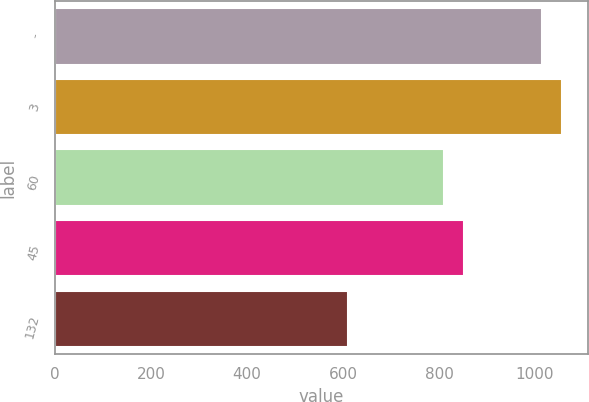Convert chart to OTSL. <chart><loc_0><loc_0><loc_500><loc_500><bar_chart><fcel>-<fcel>3<fcel>60<fcel>45<fcel>132<nl><fcel>1014<fcel>1057.1<fcel>810<fcel>853.1<fcel>611<nl></chart> 